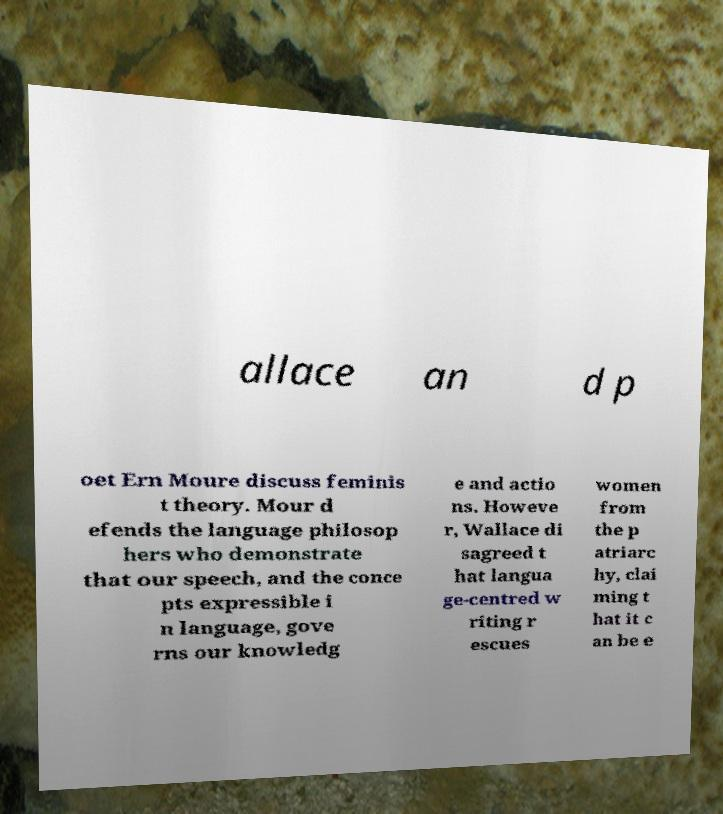I need the written content from this picture converted into text. Can you do that? allace an d p oet Ern Moure discuss feminis t theory. Mour d efends the language philosop hers who demonstrate that our speech, and the conce pts expressible i n language, gove rns our knowledg e and actio ns. Howeve r, Wallace di sagreed t hat langua ge-centred w riting r escues women from the p atriarc hy, clai ming t hat it c an be e 